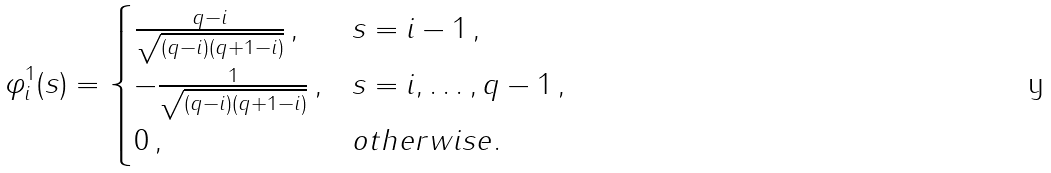Convert formula to latex. <formula><loc_0><loc_0><loc_500><loc_500>\varphi _ { i } ^ { 1 } ( s ) = \begin{cases} \frac { q - i } { \sqrt { ( q - i ) ( q + 1 - i ) } } \, , & s = i - 1 \, , \\ - \frac { 1 } { \sqrt { ( q - i ) ( q + 1 - i ) } } \, , & s = i , \dots , q - 1 \, , \\ 0 \, , & o t h e r w i s e . \end{cases}</formula> 